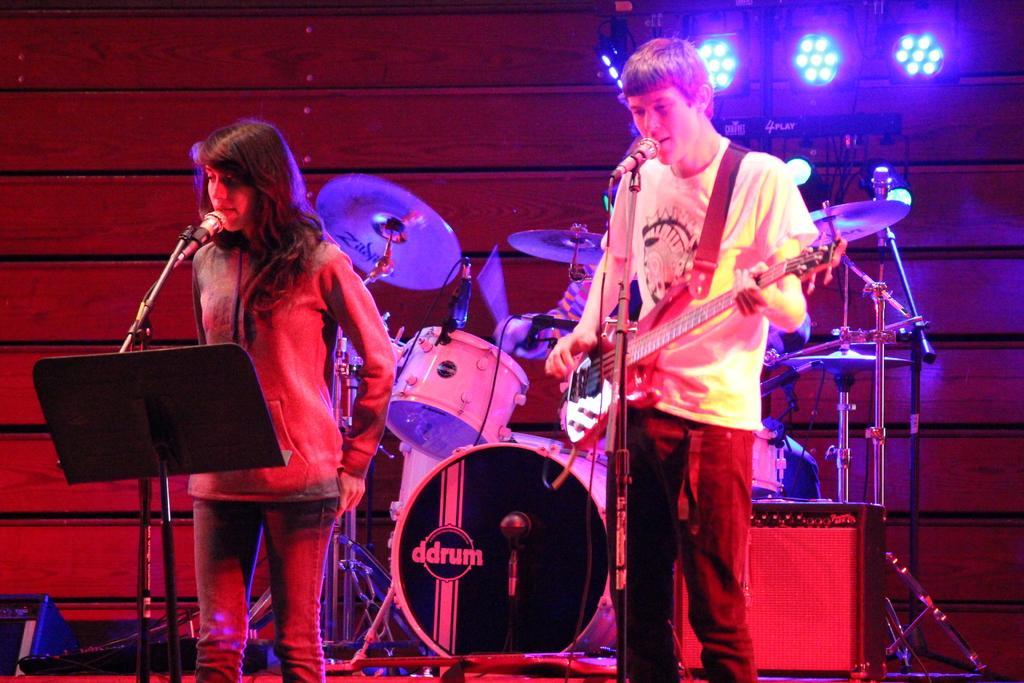In one or two sentences, can you explain what this image depicts? In this image I can see there are two persons standing in front of the mike , they are playing a music and holding a musical instrument ,background I can see some musical instruments kept on the floor and In the background I can see lights. 